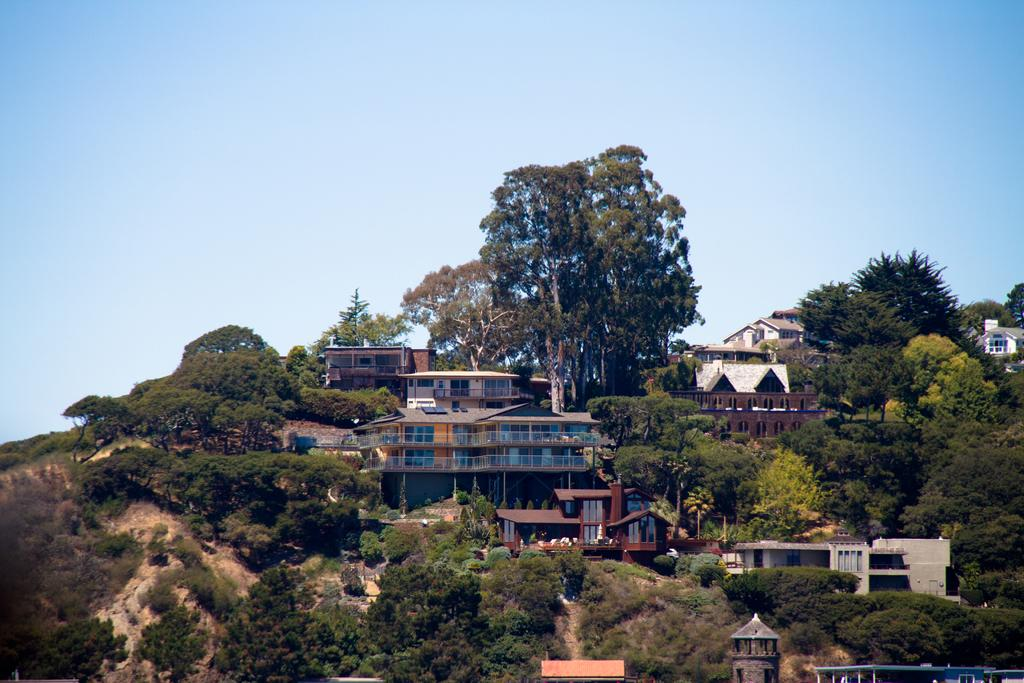What type of structures can be seen in the image? There are buildings, sheds, and a tower in the image. What type of vegetation is present in the image? There are trees in the image. What type of seating is available in the image? There is a bench in the image. What type of natural landform is visible in the image? There are hills in the image. What is visible at the top of the image? The sky is visible at the top of the image. What shape is the chicken in the image? There is no chicken present in the image. What is the tendency of the hills in the image? The image does not indicate any specific tendency of the hills; it only shows their presence. 